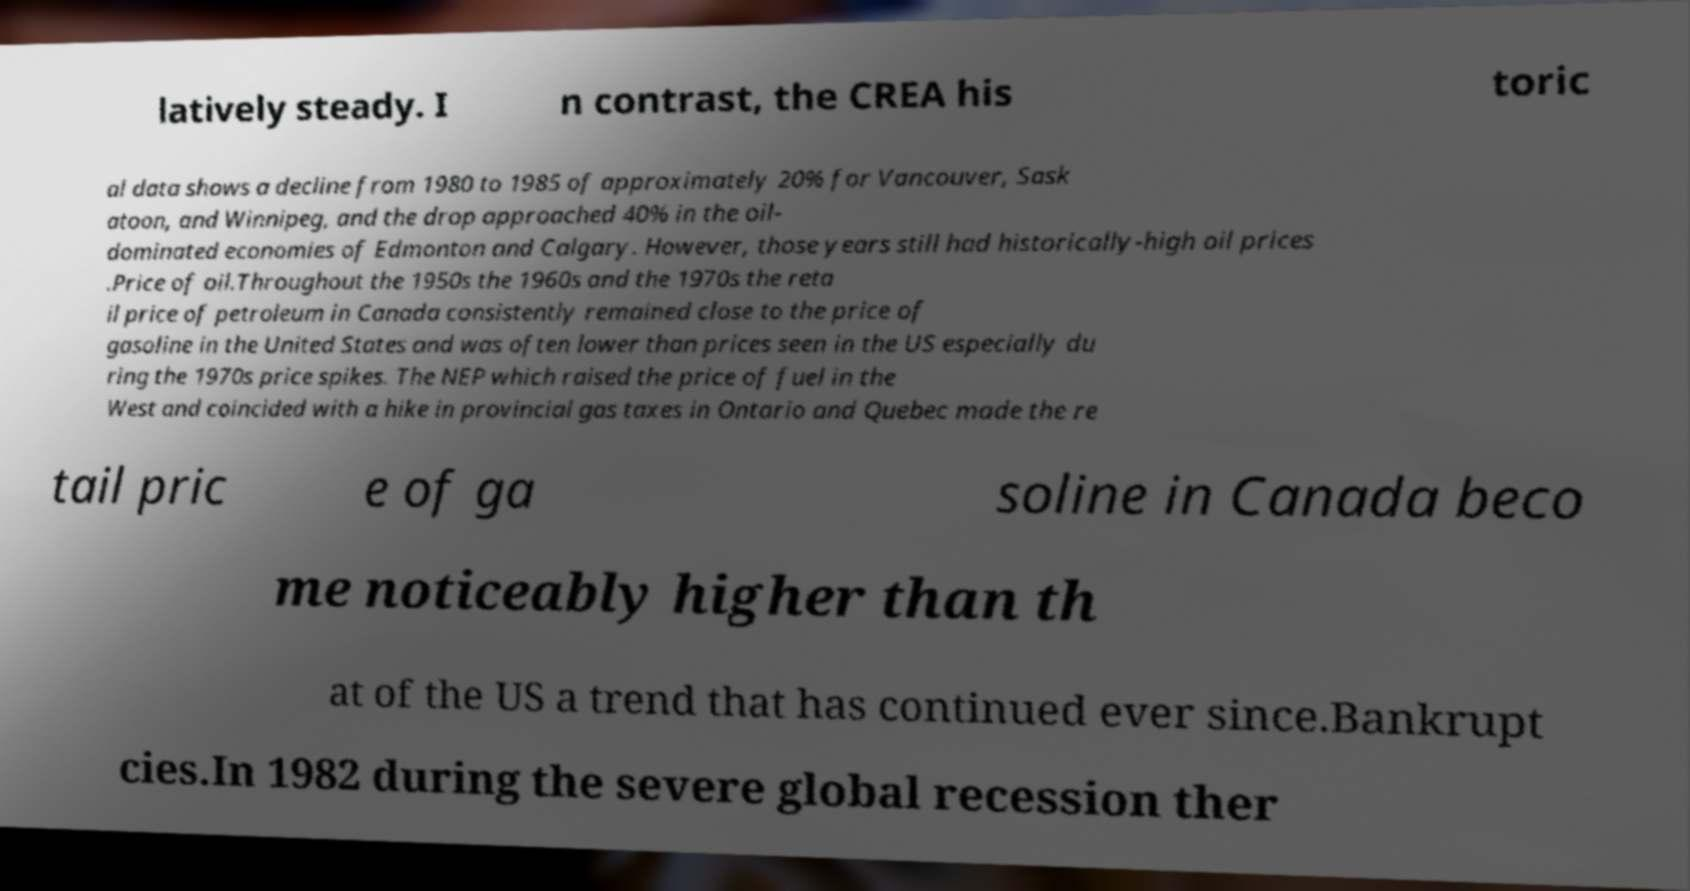Could you extract and type out the text from this image? latively steady. I n contrast, the CREA his toric al data shows a decline from 1980 to 1985 of approximately 20% for Vancouver, Sask atoon, and Winnipeg, and the drop approached 40% in the oil- dominated economies of Edmonton and Calgary. However, those years still had historically-high oil prices .Price of oil.Throughout the 1950s the 1960s and the 1970s the reta il price of petroleum in Canada consistently remained close to the price of gasoline in the United States and was often lower than prices seen in the US especially du ring the 1970s price spikes. The NEP which raised the price of fuel in the West and coincided with a hike in provincial gas taxes in Ontario and Quebec made the re tail pric e of ga soline in Canada beco me noticeably higher than th at of the US a trend that has continued ever since.Bankrupt cies.In 1982 during the severe global recession ther 